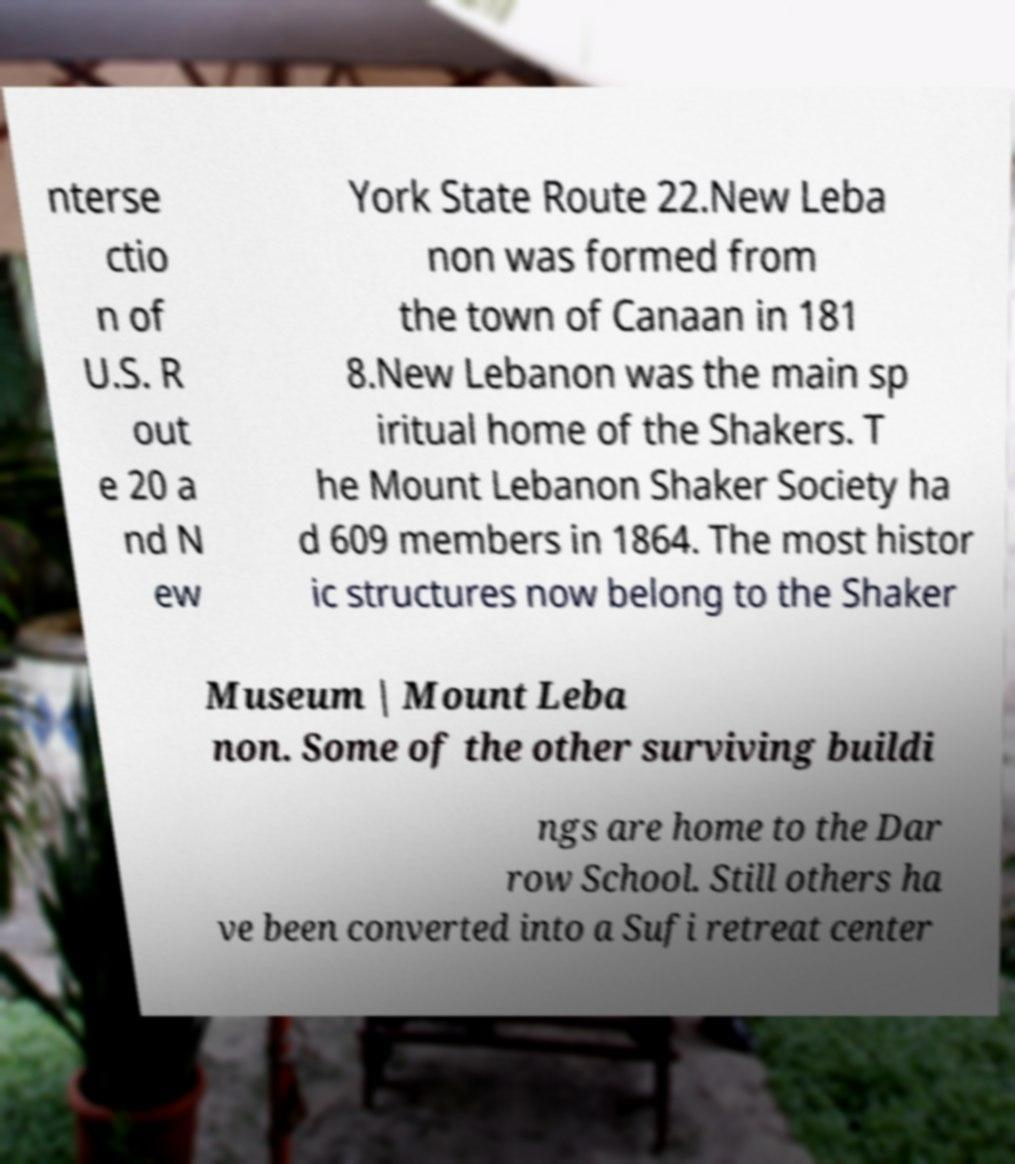Can you accurately transcribe the text from the provided image for me? nterse ctio n of U.S. R out e 20 a nd N ew York State Route 22.New Leba non was formed from the town of Canaan in 181 8.New Lebanon was the main sp iritual home of the Shakers. T he Mount Lebanon Shaker Society ha d 609 members in 1864. The most histor ic structures now belong to the Shaker Museum | Mount Leba non. Some of the other surviving buildi ngs are home to the Dar row School. Still others ha ve been converted into a Sufi retreat center 